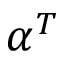<formula> <loc_0><loc_0><loc_500><loc_500>\alpha ^ { T }</formula> 